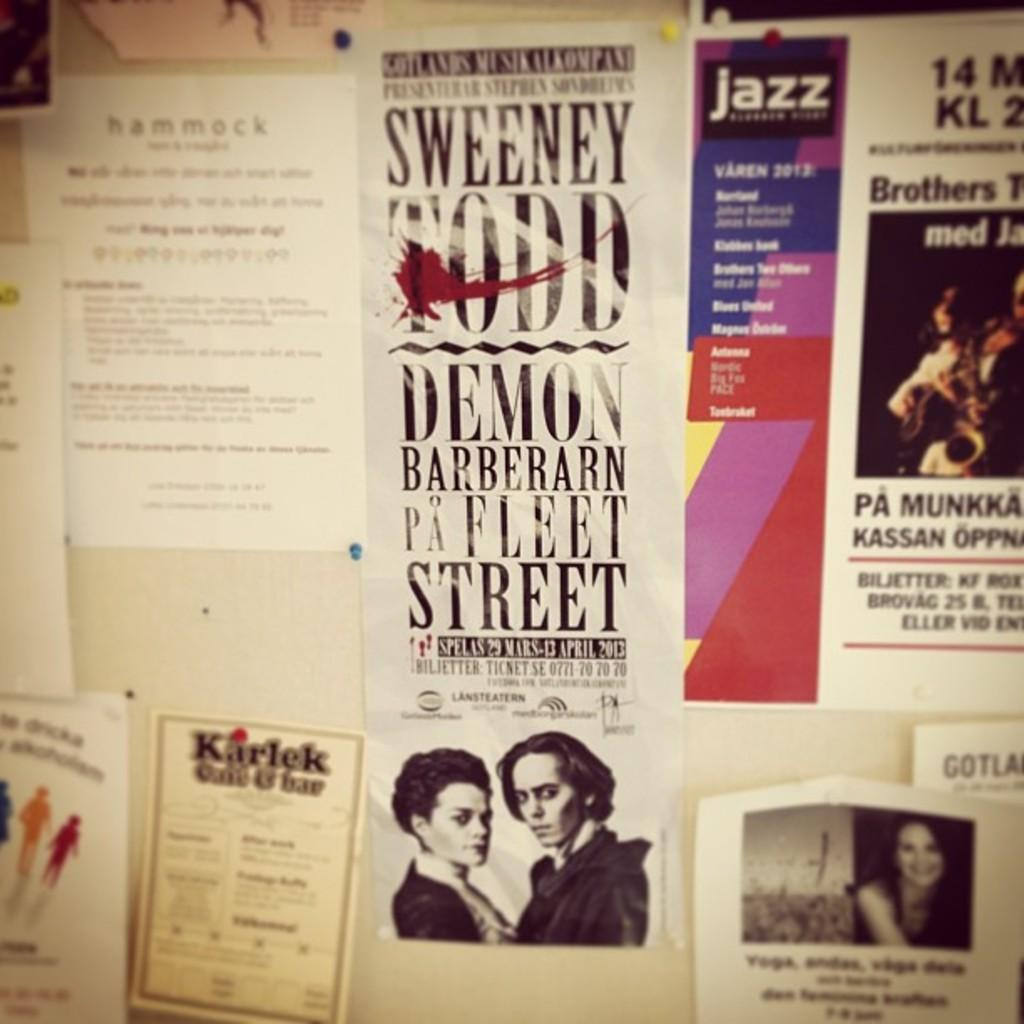Provide a one-sentence caption for the provided image. A billboard filled with flyers including "Sweeney Todd, Demon Barberarn Pa Fleet Street". 